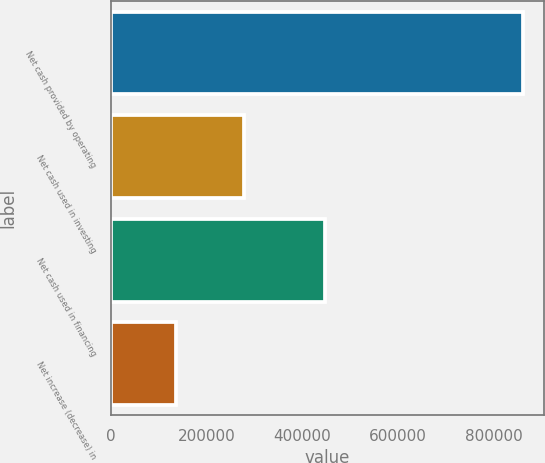Convert chart. <chart><loc_0><loc_0><loc_500><loc_500><bar_chart><fcel>Net cash provided by operating<fcel>Net cash used in investing<fcel>Net cash used in financing<fcel>Net increase (decrease) in<nl><fcel>861454<fcel>278334<fcel>447091<fcel>136029<nl></chart> 